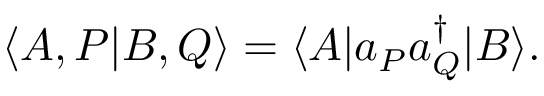<formula> <loc_0><loc_0><loc_500><loc_500>\langle A , P | B , Q \rangle = \langle A | a _ { P } a _ { Q } ^ { \dagger } | B \rangle .</formula> 